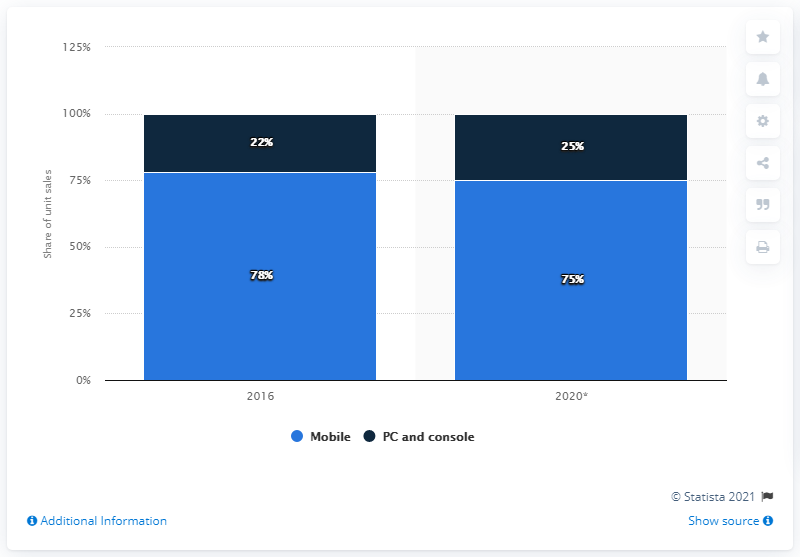Identify some key points in this picture. In 2020, the difference between the sales of mobile devices and those of PC gaming consoles was smallest. In 2016, the sales of mobile devices accounted for approximately 78% of the total revenue generated by the technology industry. 